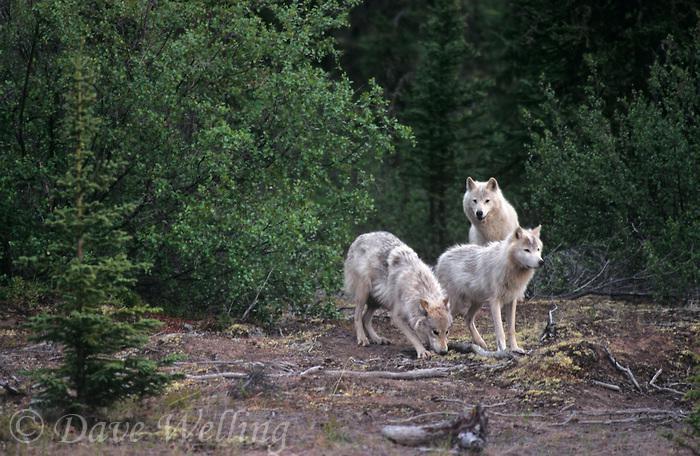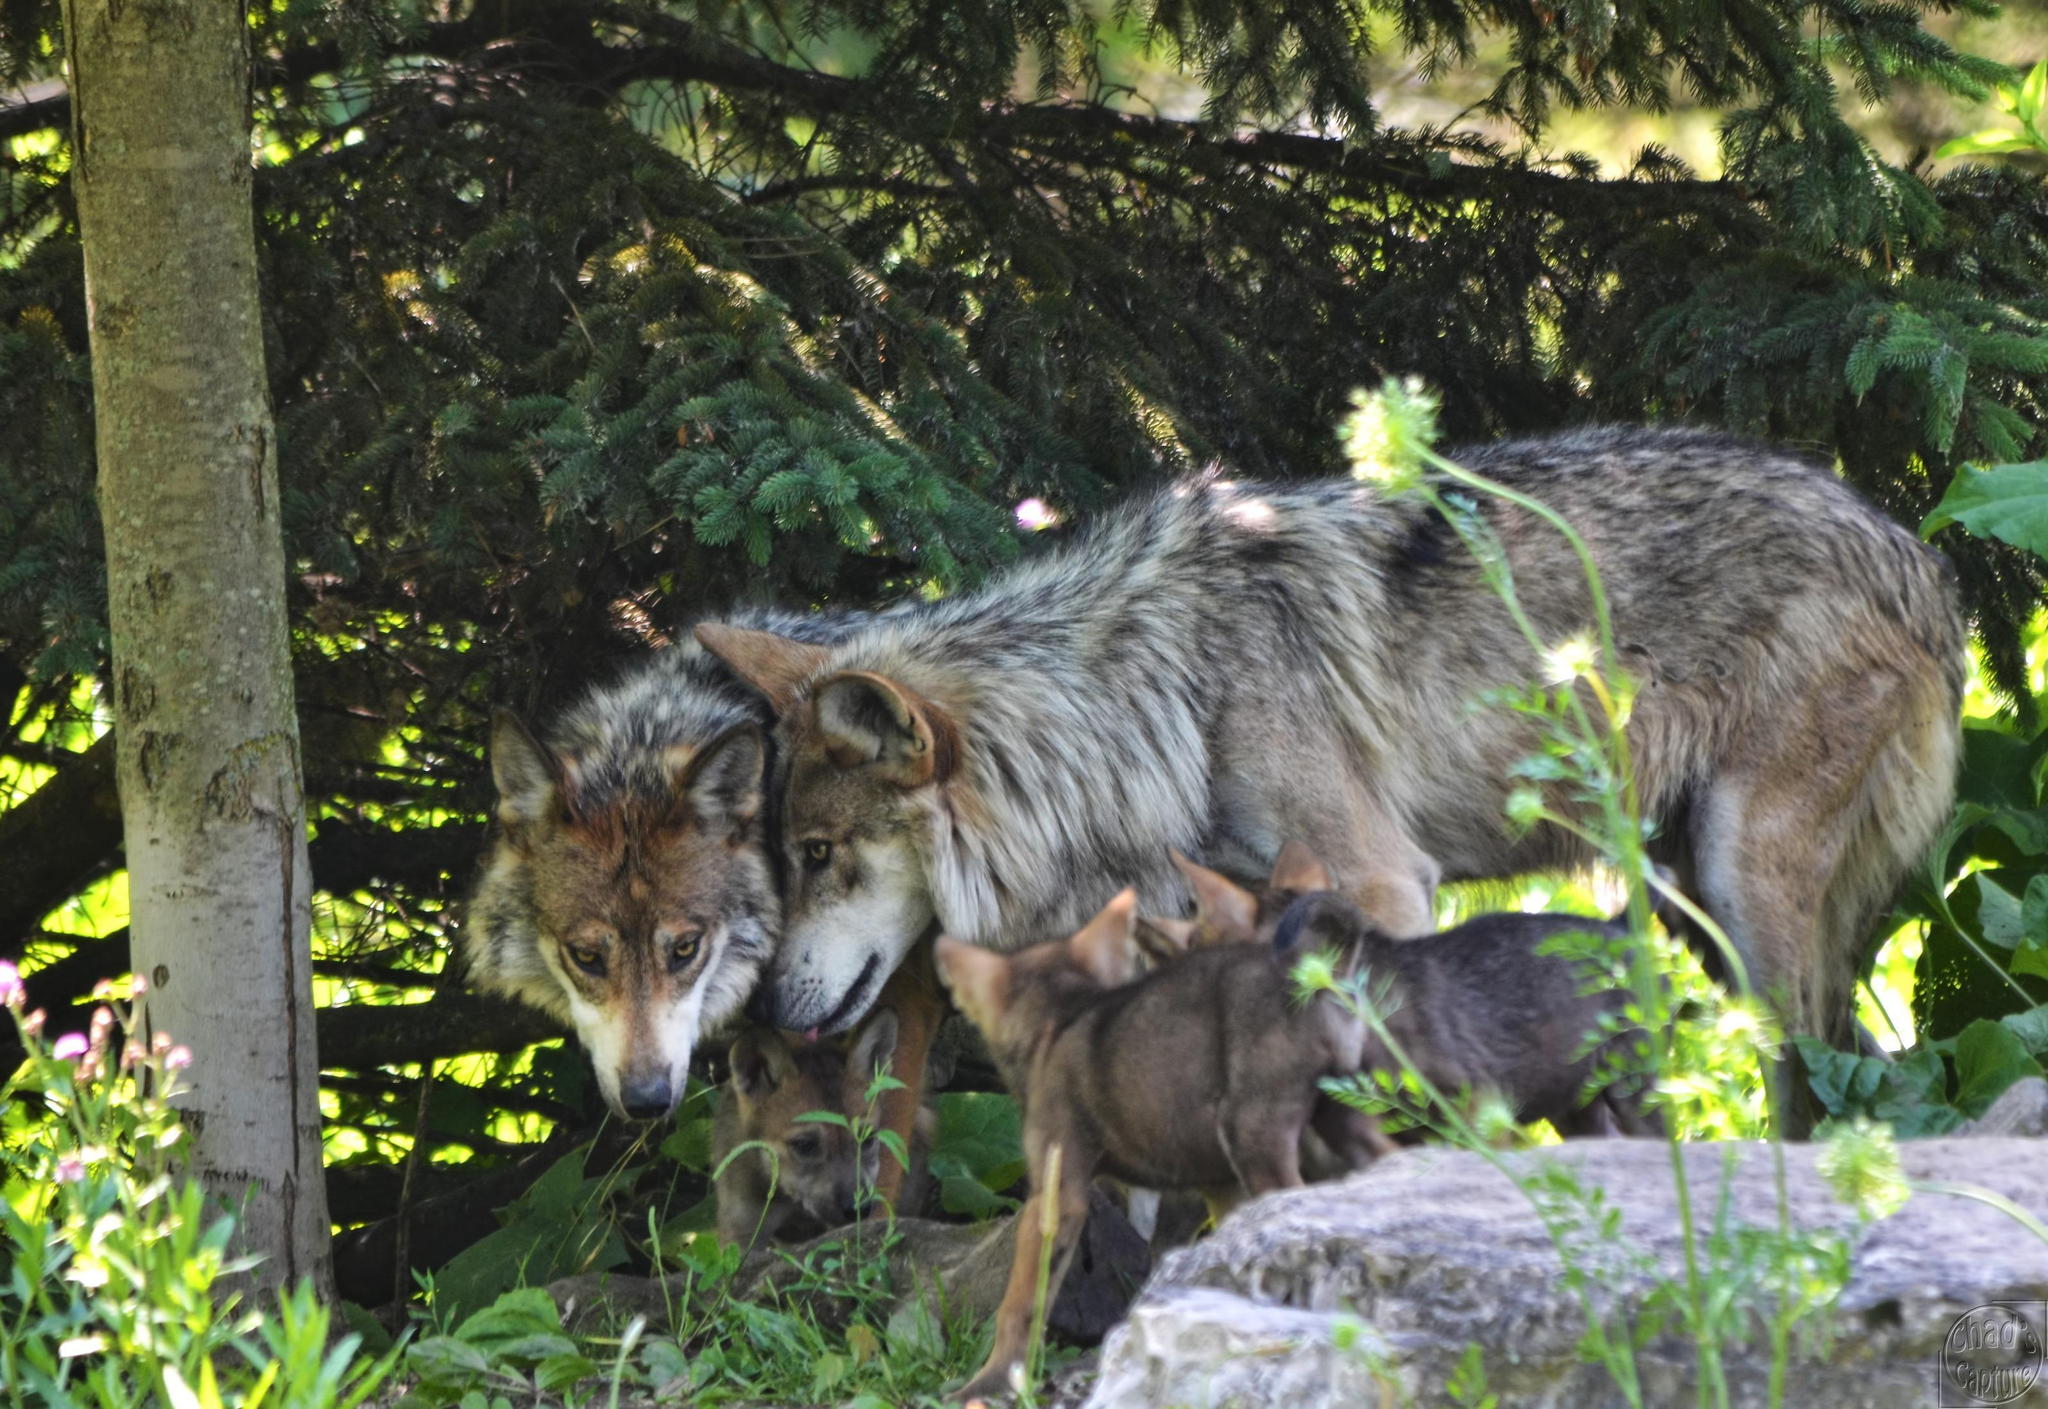The first image is the image on the left, the second image is the image on the right. Evaluate the accuracy of this statement regarding the images: "Some of the wolves in one of the images are lying down on the ground.". Is it true? Answer yes or no. No. The first image is the image on the left, the second image is the image on the right. For the images shown, is this caption "The image on the left includes at least one adult wolf standing on all fours, and the image on the right includes three wolf pups." true? Answer yes or no. Yes. 